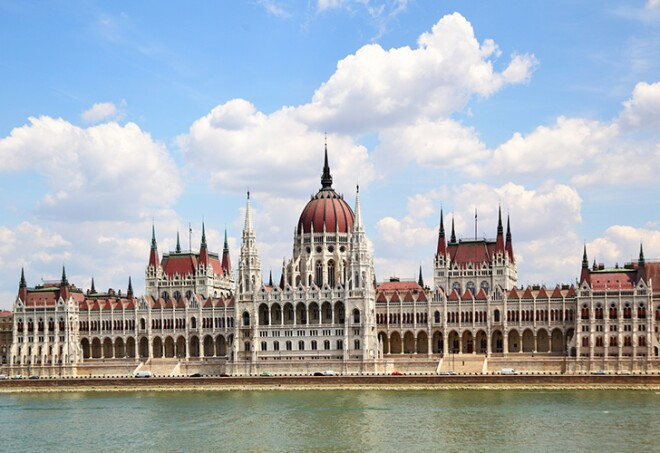Can you describe any features of the Hungarian Parliament Building that reflect its political history? Certainly! The Hungarian Parliament Building is steeped in political history, which is subtly reflected in its intricate design. For instance, the grand dome symbolizes national unity, standing as a proud testament to Hungary's sovereignty. The extensive use of Gothic Revival architecture was chosen to symbolize the nation's past strength and grandeur while embracing the spirit of democracy and forward-looking ideals. The statues of Hungarian rulers and military figures adorning the facade signify the country's turbulent history and struggle for independence. Inside, the Holy Crown of Hungary is housed under the central dome, symbolizing the historical and cultural continuity of the nation. The central dome seems very prominent. Why was it designed this way? The central dome of the Hungarian Parliament Building is designed to be a focal point of the structure, symbolizing the heart of the nation. Beyond its aesthetic appeal, the dome serves a practical purpose as the legislative center of Hungary. It marks the central hall, beneath which the Holy Crown of Hungary is displayed. This places the kingdom's history and democratic governance literally and metaphorically at the heart of the nation's political life. The dome's prominence also reflects the architectural trend of monumental domes during the period it was built, as a way of demonstrating power and grandeur. Imagine if the Hungarian Parliament Building could speak. What stories might it share from its perspective? If the Hungarian Parliament Building could speak, it might recount tales of its construction, a project that took nearly two decades and involved thousands of skilled workers. It might share the excitement and optimism during its completion at the dawn of the 20th century, a symbol of Hungary's golden age. The building could narrate the somber times it witnessed during World War II and the subsequent Soviet occupation, serving as a silent observer to political upheavals and social changes. It might also tell of the joyous moments of national celebration, such as the reestablishment of democracy in 1989, along with countless parliamentary debates and decisions that have shaped the nation. Ultimately, the building would speak of resilience and continuity, standing tall through the nation's complex and storied history. 